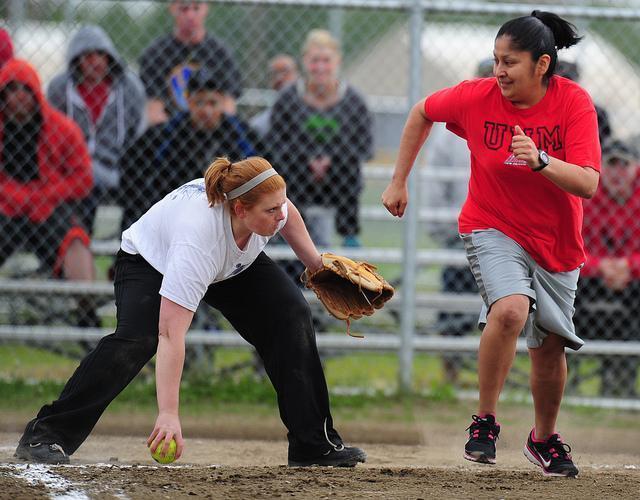How many people are there?
Give a very brief answer. 8. 